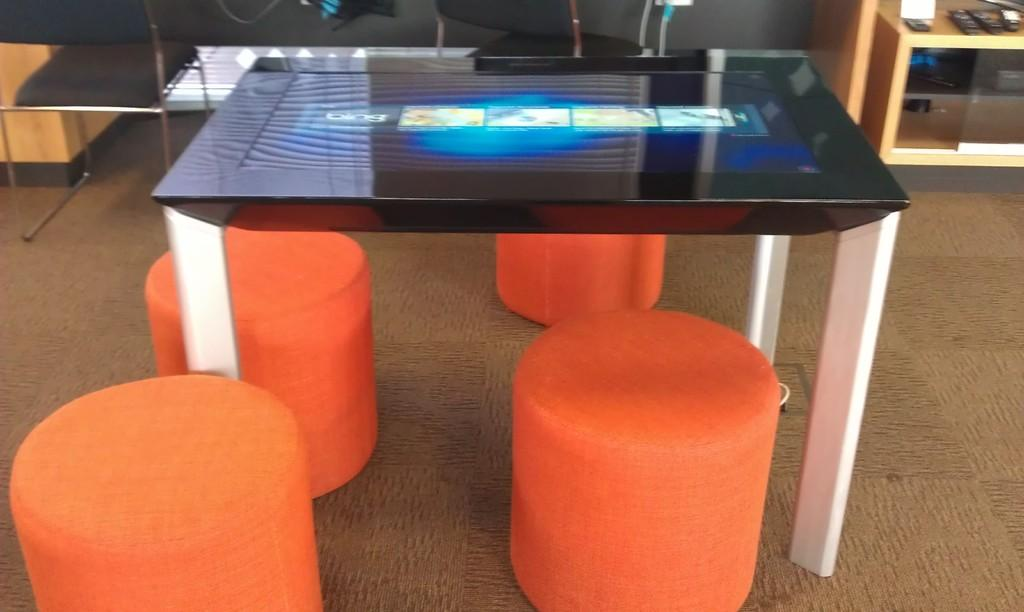What type of furniture is present in the image? There is a table in the image. What is on top of the table? There is a screen on the table. What type of seating is available in the image? There are stools in the image. What can be used to control the screen? There are remotes in the image. What other objects are on the table? There are other objects on the table. Where is the clock located in the image? There is no clock present in the image. Can you see a swing in the image? There is no swing present in the image. 